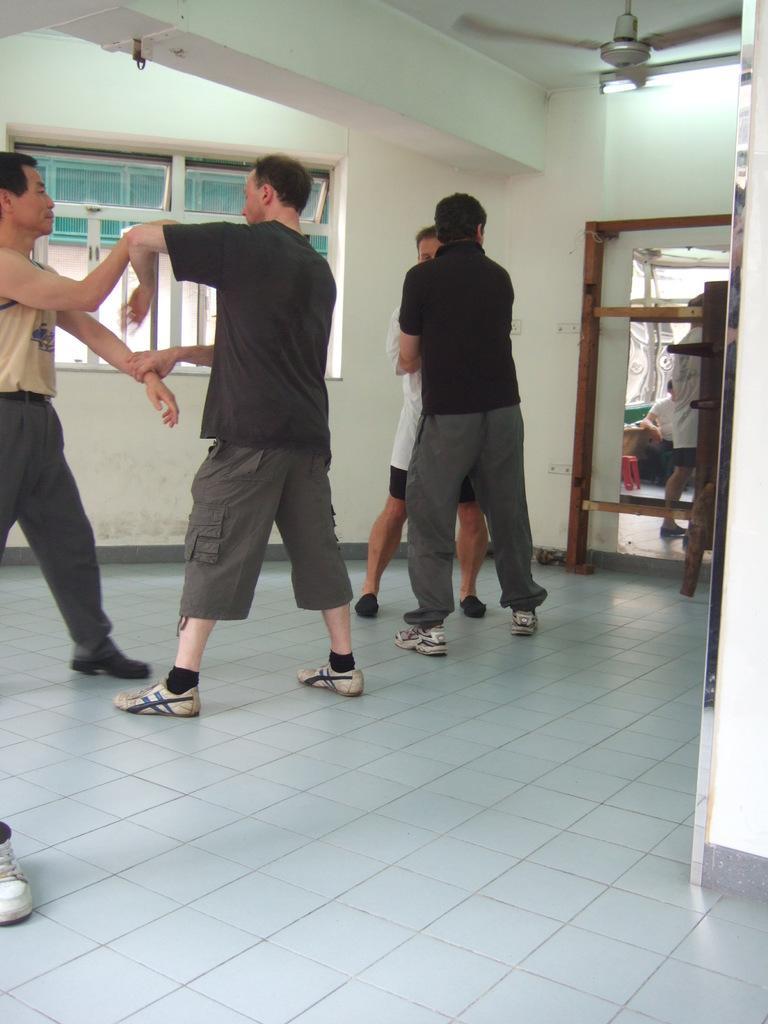Can you describe this image briefly? In this image there are few persons standing on the floor. Right side there is a door. Behind it there are few persons. Right top there is a fan attached to the roof. Background there is a wall having windows. 